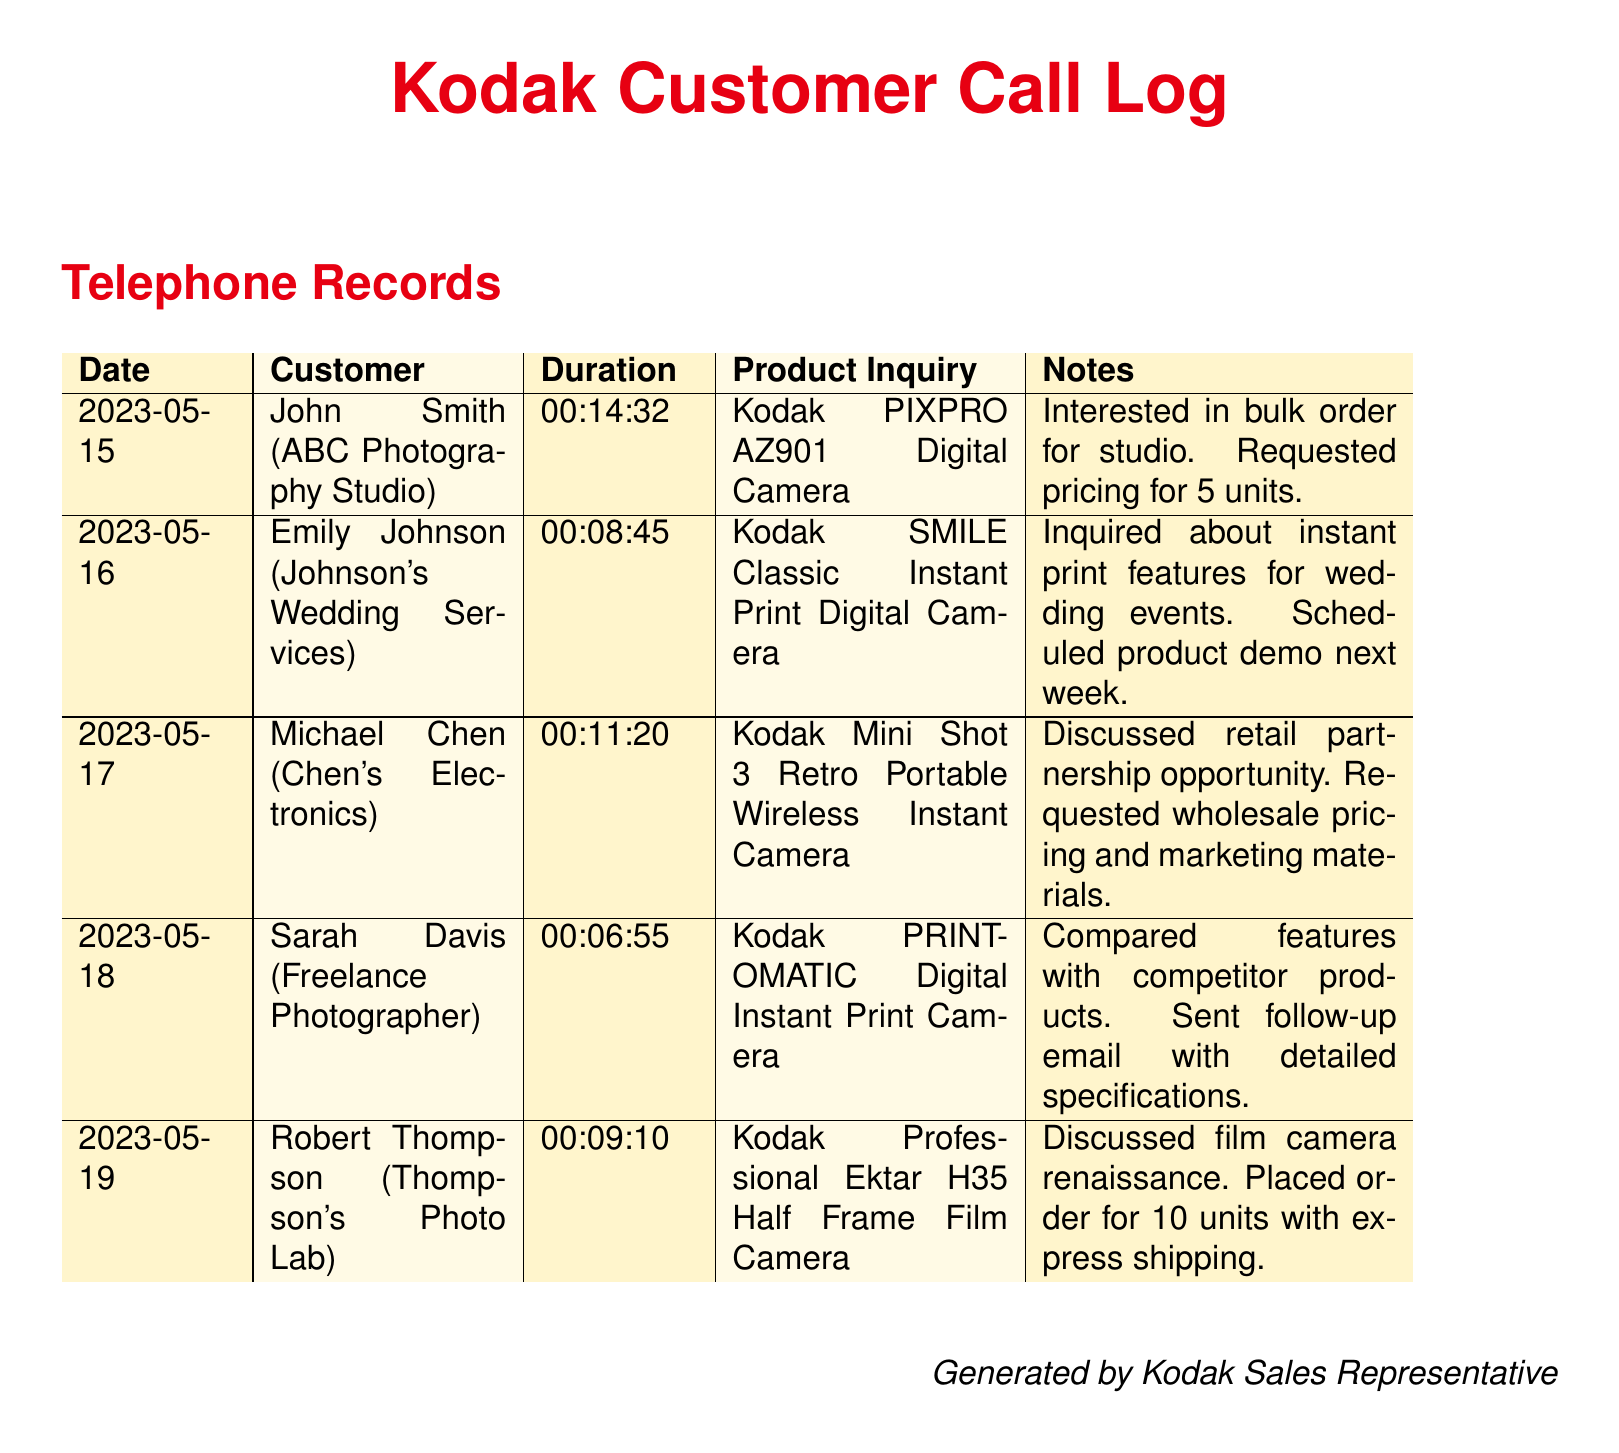What is the date of the call with John Smith? The call with John Smith took place on May 15, 2023.
Answer: May 15, 2023 What product did Emily Johnson inquire about? Emily Johnson inquired about the Kodak SMILE Classic Instant Print Digital Camera.
Answer: Kodak SMILE Classic Instant Print Digital Camera How long was the call with Sarah Davis? The duration of the call with Sarah Davis was 6 minutes and 55 seconds.
Answer: 00:06:55 What was requested by John Smith during his call? John Smith requested pricing for 5 units of the Kodak PIXPRO AZ901 Digital Camera.
Answer: Pricing for 5 units How many units did Robert Thompson order? Robert Thompson placed an order for 10 units of the Kodak Professional Ektar H35 Half Frame Film Camera.
Answer: 10 units Which customer discussed a retail partnership opportunity? Michael Chen from Chen's Electronics discussed a retail partnership opportunity.
Answer: Michael Chen What was the follow-up action taken after Sarah Davis's call? A follow-up email with detailed specifications was sent after Sarah Davis's call.
Answer: Sent follow-up email What event was Emily Johnson planning for? Emily Johnson was planning for wedding events.
Answer: Wedding events Which camera was discussed in the context of a film camera renaissance? The Kodak Professional Ektar H35 Half Frame Film Camera was discussed in this context.
Answer: Kodak Professional Ektar H35 Half Frame Film Camera 